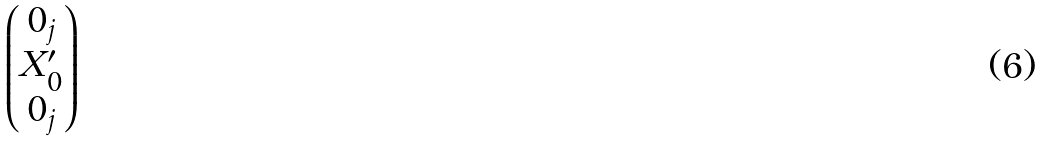<formula> <loc_0><loc_0><loc_500><loc_500>\begin{pmatrix} 0 _ { j } \\ X ^ { \prime } _ { 0 } \\ 0 _ { j } \end{pmatrix}</formula> 